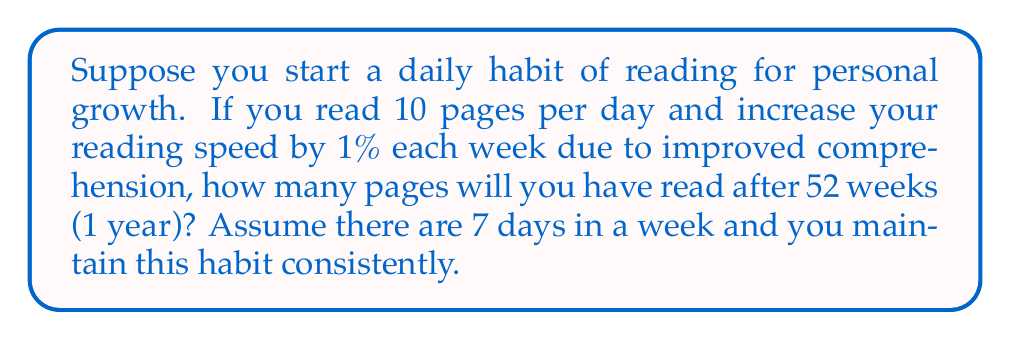Provide a solution to this math problem. Let's approach this step-by-step:

1) First, we need to calculate the number of pages read each week, considering the increasing reading speed:

   Week 1: $10 \times 7 = 70$ pages
   Week 2: $10 \times 1.01 \times 7 = 70.7$ pages
   Week 3: $10 \times 1.01^2 \times 7 = 71.407$ pages
   ...and so on.

2) We can represent this as a geometric series:

   $S = 70 + 70(1.01) + 70(1.01)^2 + ... + 70(1.01)^{51}$

3) The sum of a geometric series is given by the formula:

   $S = \frac{a(1-r^n)}{1-r}$

   Where:
   $a = 70$ (first term)
   $r = 1.01$ (common ratio)
   $n = 52$ (number of terms)

4) Plugging in these values:

   $S = \frac{70(1-1.01^{52})}{1-1.01}$

5) Calculating this:

   $S = \frac{70(1-1.6805)}{-0.01} = 4763.5$ pages

6) Since we can't read partial pages, we round down to the nearest whole number.
Answer: 4763 pages 